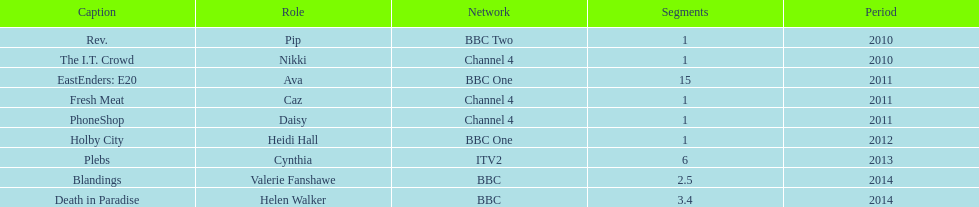How many titles only had one episode? 5. 